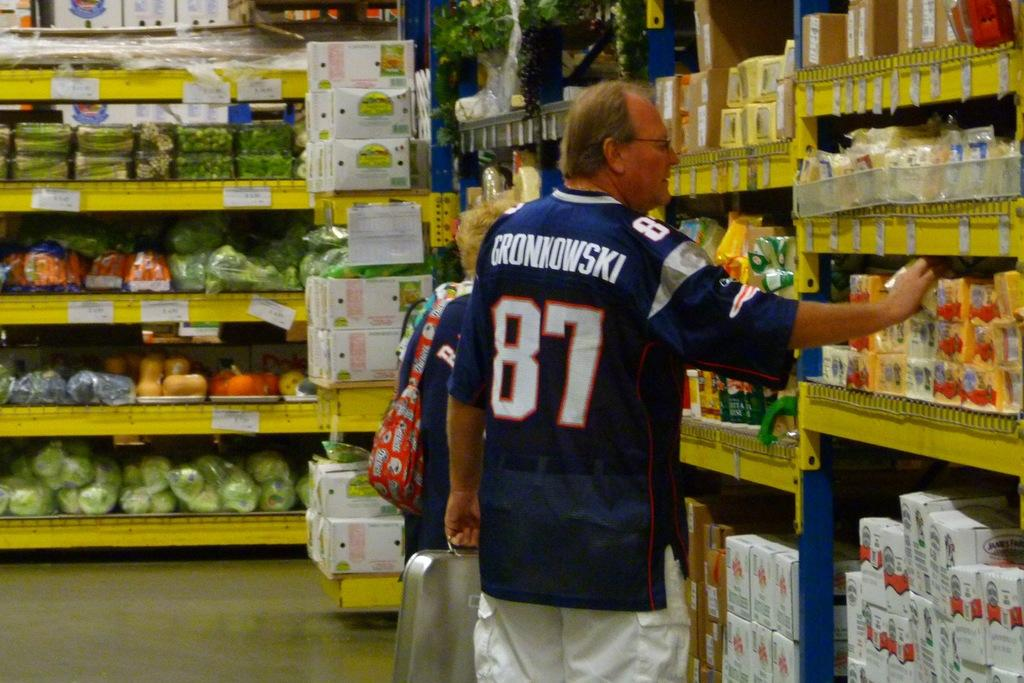<image>
Relay a brief, clear account of the picture shown. A man in a number 87 jersey is shopping at the grocery store. 